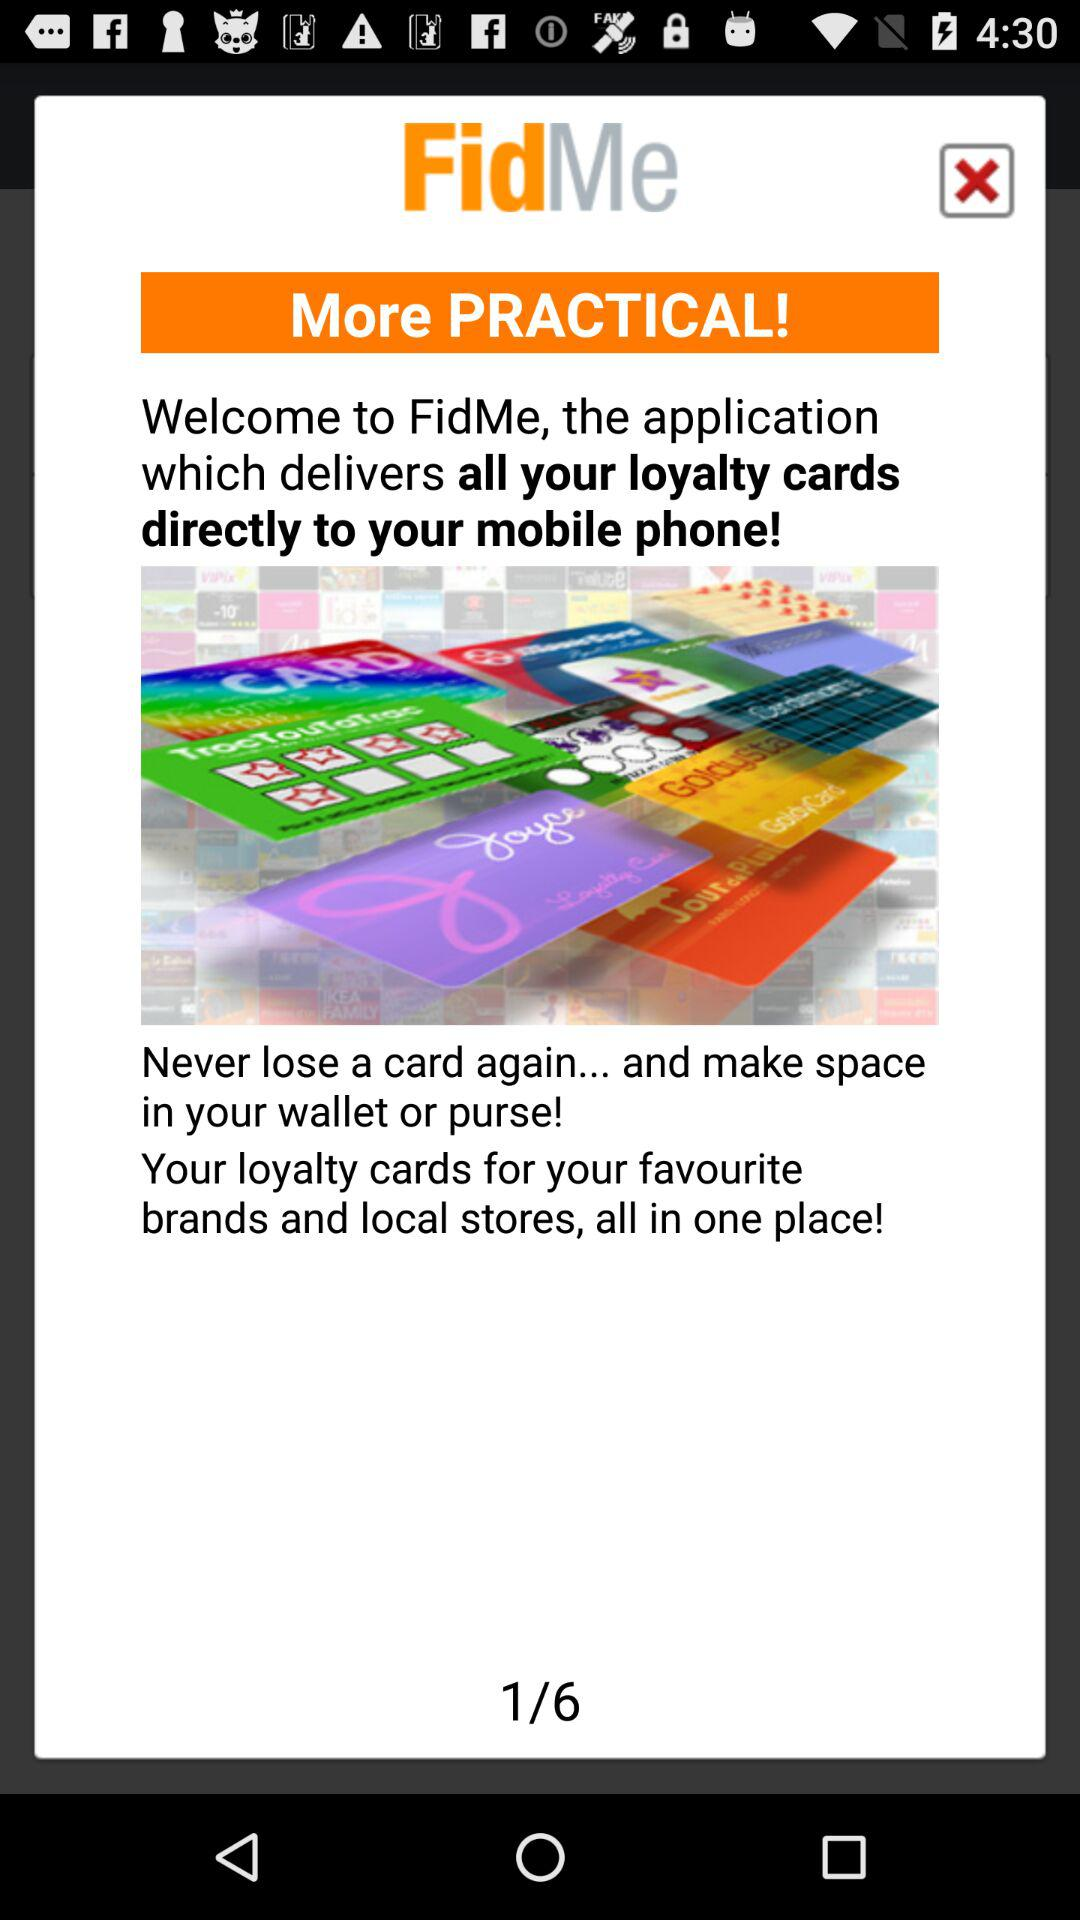How many total pages are there? There are six pages in total. 